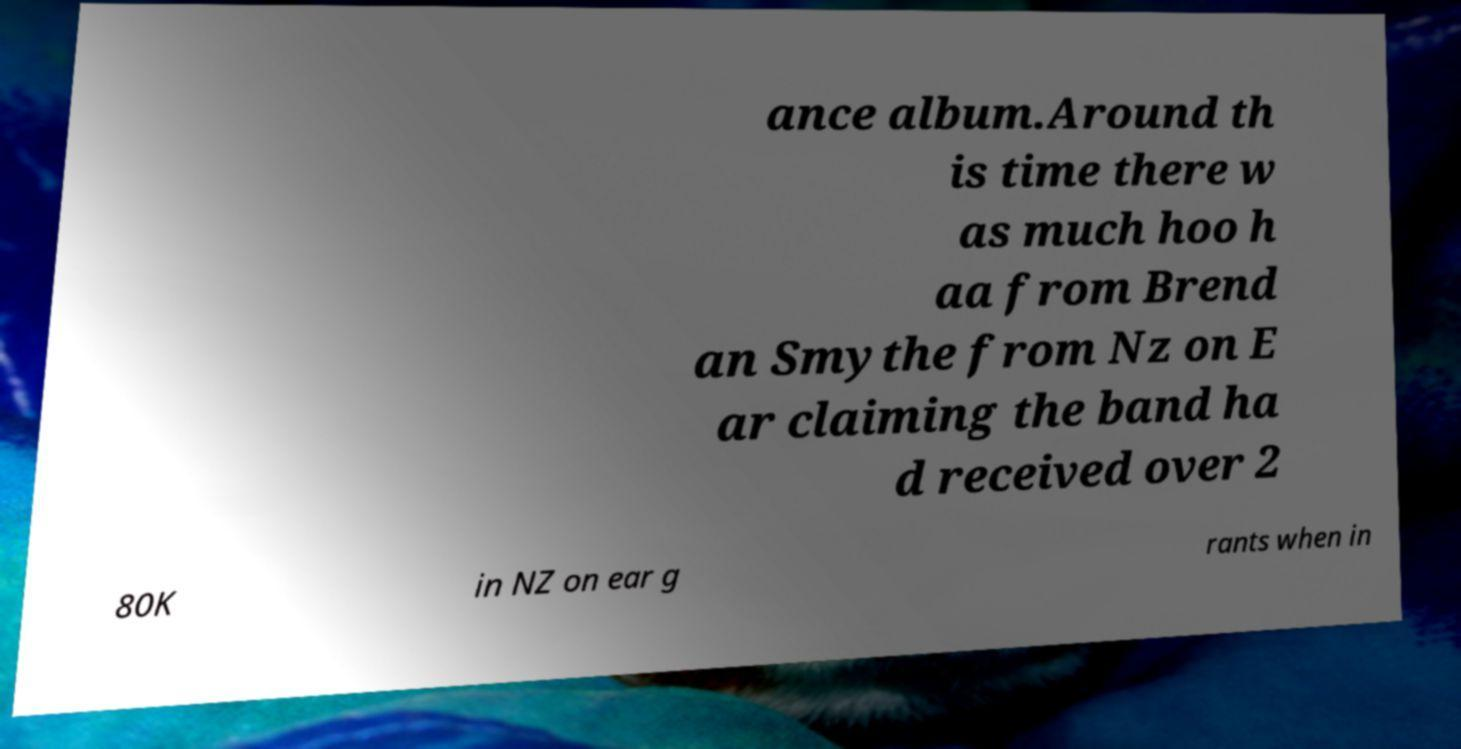What messages or text are displayed in this image? I need them in a readable, typed format. ance album.Around th is time there w as much hoo h aa from Brend an Smythe from Nz on E ar claiming the band ha d received over 2 80K in NZ on ear g rants when in 